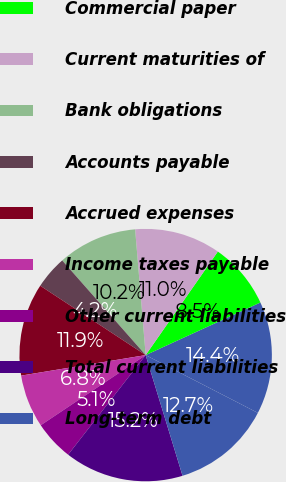Convert chart. <chart><loc_0><loc_0><loc_500><loc_500><pie_chart><fcel>December 31<fcel>Commercial paper<fcel>Current maturities of<fcel>Bank obligations<fcel>Accounts payable<fcel>Accrued expenses<fcel>Income taxes payable<fcel>Other current liabilities<fcel>Total current liabilities<fcel>Long-term debt<nl><fcel>14.41%<fcel>8.47%<fcel>11.02%<fcel>10.17%<fcel>4.24%<fcel>11.86%<fcel>6.78%<fcel>5.09%<fcel>15.25%<fcel>12.71%<nl></chart> 